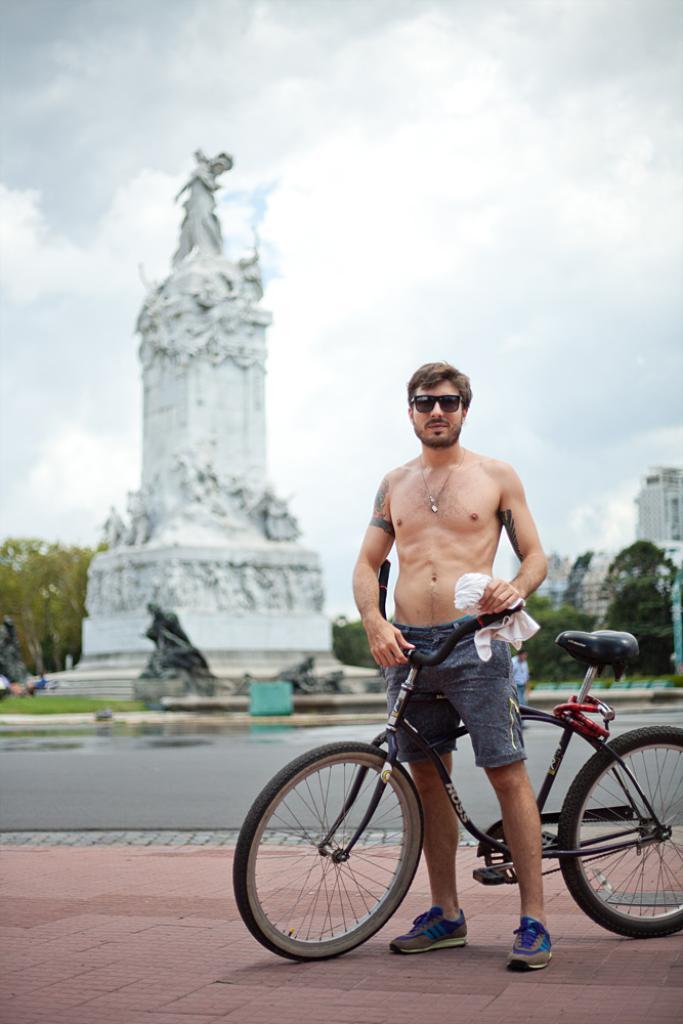Can you describe this image briefly? A person is holding bicycle in his hand. Behind him there is a statue,trees,buildings and cloudy sky. 